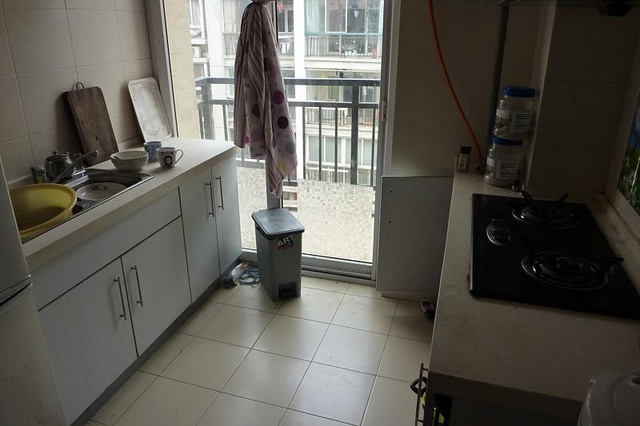Describe the objects in this image and their specific colors. I can see oven in gray, black, and darkgray tones, refrigerator in gray and black tones, bottle in gray and black tones, bowl in gray, olive, and black tones, and sink in gray and black tones in this image. 